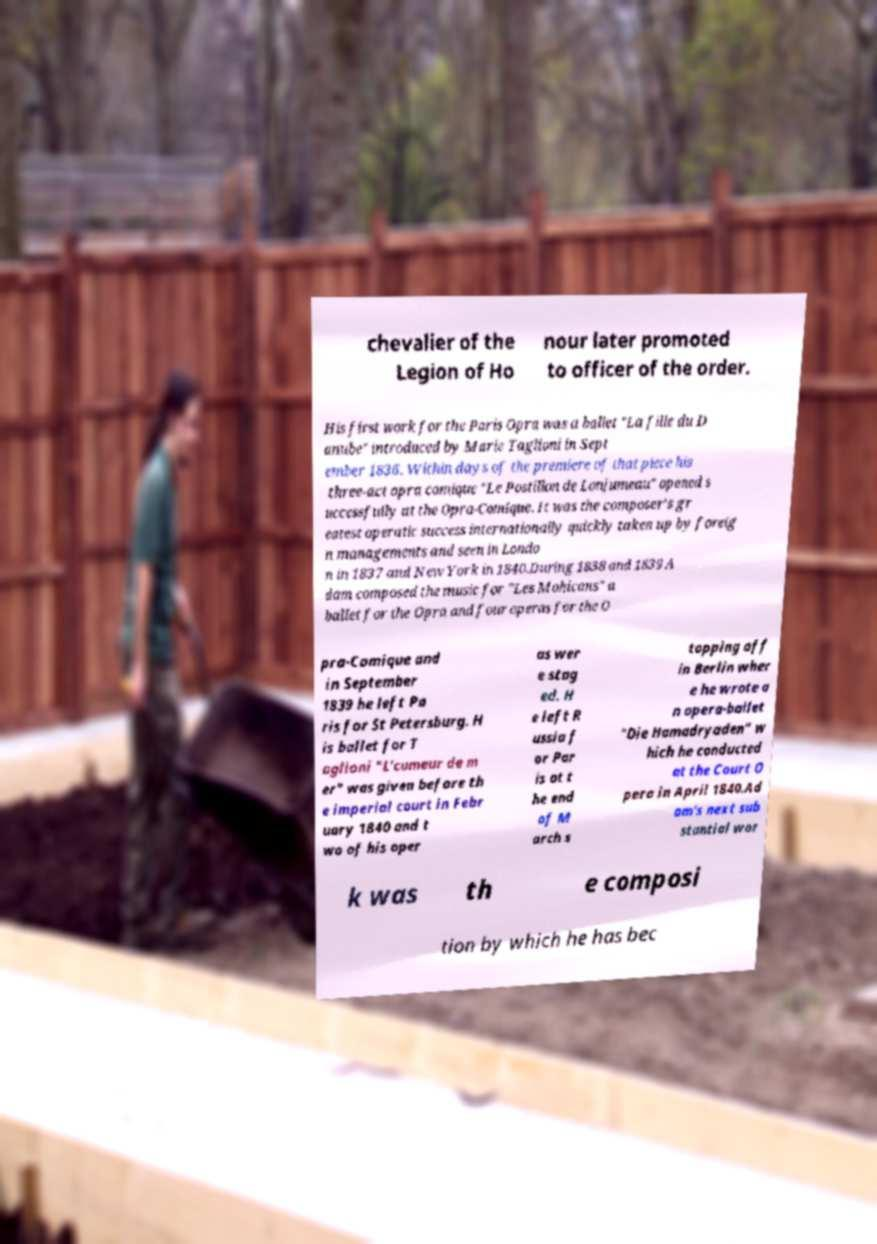Can you accurately transcribe the text from the provided image for me? chevalier of the Legion of Ho nour later promoted to officer of the order. His first work for the Paris Opra was a ballet "La fille du D anube" introduced by Marie Taglioni in Sept ember 1836. Within days of the premiere of that piece his three-act opra comique "Le Postillon de Lonjumeau" opened s uccessfully at the Opra-Comique. It was the composer's gr eatest operatic success internationally quickly taken up by foreig n managements and seen in Londo n in 1837 and New York in 1840.During 1838 and 1839 A dam composed the music for "Les Mohicans" a ballet for the Opra and four operas for the O pra-Comique and in September 1839 he left Pa ris for St Petersburg. H is ballet for T aglioni "L'cumeur de m er" was given before th e imperial court in Febr uary 1840 and t wo of his oper as wer e stag ed. H e left R ussia f or Par is at t he end of M arch s topping off in Berlin wher e he wrote a n opera-ballet "Die Hamadryaden" w hich he conducted at the Court O pera in April 1840.Ad am's next sub stantial wor k was th e composi tion by which he has bec 